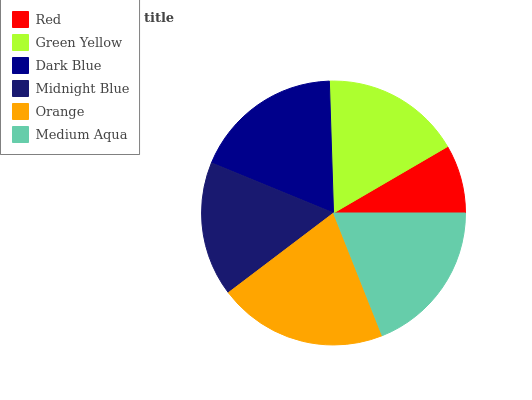Is Red the minimum?
Answer yes or no. Yes. Is Orange the maximum?
Answer yes or no. Yes. Is Green Yellow the minimum?
Answer yes or no. No. Is Green Yellow the maximum?
Answer yes or no. No. Is Green Yellow greater than Red?
Answer yes or no. Yes. Is Red less than Green Yellow?
Answer yes or no. Yes. Is Red greater than Green Yellow?
Answer yes or no. No. Is Green Yellow less than Red?
Answer yes or no. No. Is Dark Blue the high median?
Answer yes or no. Yes. Is Green Yellow the low median?
Answer yes or no. Yes. Is Green Yellow the high median?
Answer yes or no. No. Is Dark Blue the low median?
Answer yes or no. No. 